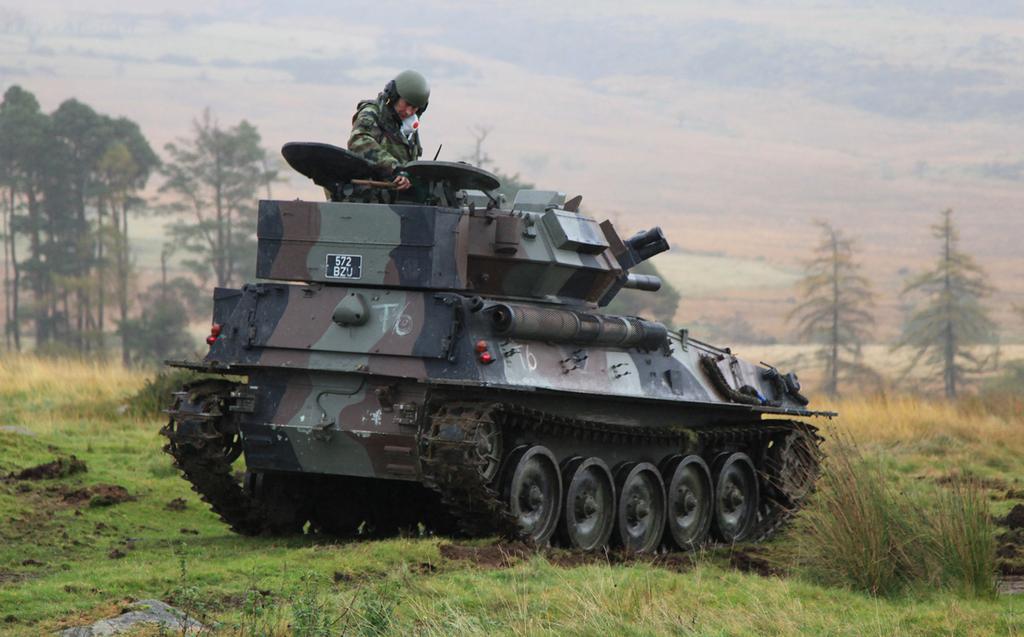In one or two sentences, can you explain what this image depicts? In the picture we can see a tanker in which a person wearing uniform and helmet is standing. Here we can see the grass, plants, trees and the background of the image is covered with fog. 